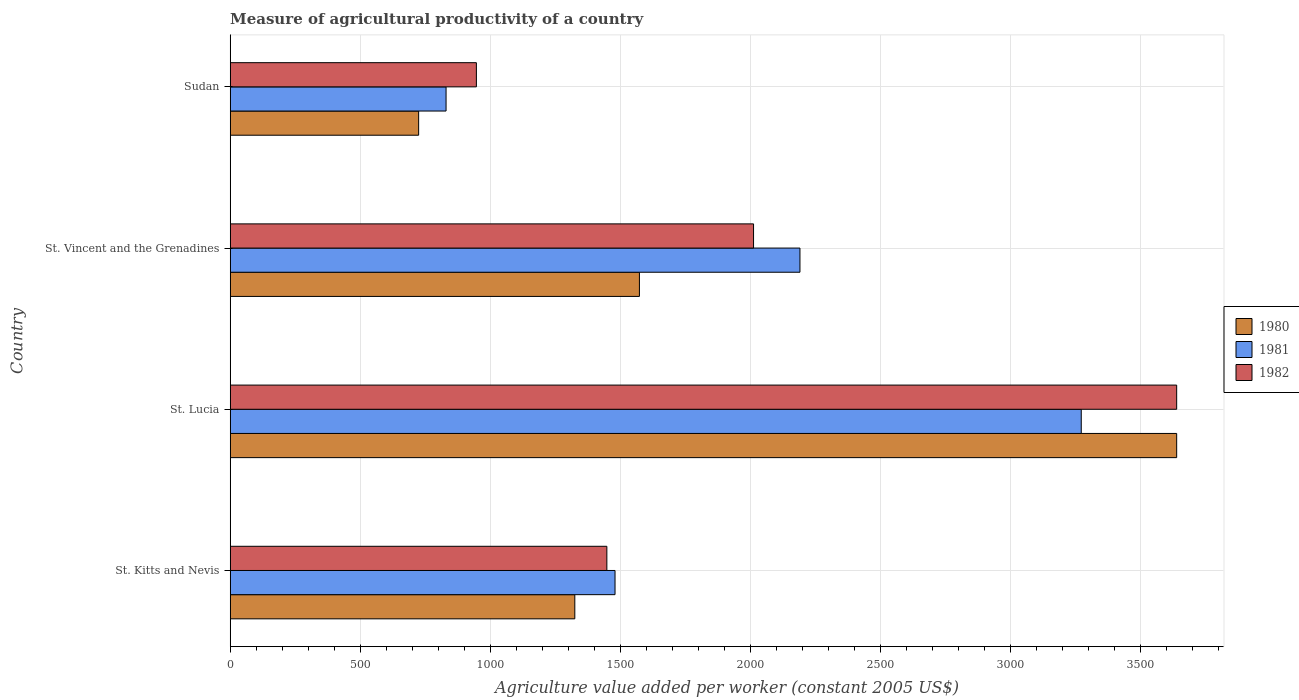How many different coloured bars are there?
Provide a short and direct response. 3. How many groups of bars are there?
Offer a very short reply. 4. Are the number of bars on each tick of the Y-axis equal?
Keep it short and to the point. Yes. How many bars are there on the 2nd tick from the top?
Make the answer very short. 3. How many bars are there on the 2nd tick from the bottom?
Offer a very short reply. 3. What is the label of the 4th group of bars from the top?
Make the answer very short. St. Kitts and Nevis. In how many cases, is the number of bars for a given country not equal to the number of legend labels?
Your response must be concise. 0. What is the measure of agricultural productivity in 1980 in St. Vincent and the Grenadines?
Ensure brevity in your answer.  1573.39. Across all countries, what is the maximum measure of agricultural productivity in 1980?
Provide a short and direct response. 3638.96. Across all countries, what is the minimum measure of agricultural productivity in 1982?
Ensure brevity in your answer.  946.58. In which country was the measure of agricultural productivity in 1982 maximum?
Keep it short and to the point. St. Lucia. In which country was the measure of agricultural productivity in 1980 minimum?
Keep it short and to the point. Sudan. What is the total measure of agricultural productivity in 1981 in the graph?
Give a very brief answer. 7772.33. What is the difference between the measure of agricultural productivity in 1980 in St. Lucia and that in St. Vincent and the Grenadines?
Provide a succinct answer. 2065.57. What is the difference between the measure of agricultural productivity in 1982 in Sudan and the measure of agricultural productivity in 1981 in St. Kitts and Nevis?
Offer a very short reply. -533.02. What is the average measure of agricultural productivity in 1982 per country?
Keep it short and to the point. 2011.48. What is the difference between the measure of agricultural productivity in 1980 and measure of agricultural productivity in 1982 in St. Vincent and the Grenadines?
Offer a terse response. -438.76. What is the ratio of the measure of agricultural productivity in 1982 in St. Lucia to that in St. Vincent and the Grenadines?
Offer a terse response. 1.81. Is the difference between the measure of agricultural productivity in 1980 in St. Kitts and Nevis and St. Lucia greater than the difference between the measure of agricultural productivity in 1982 in St. Kitts and Nevis and St. Lucia?
Provide a short and direct response. No. What is the difference between the highest and the second highest measure of agricultural productivity in 1980?
Your response must be concise. 2065.57. What is the difference between the highest and the lowest measure of agricultural productivity in 1980?
Keep it short and to the point. 2914.4. In how many countries, is the measure of agricultural productivity in 1980 greater than the average measure of agricultural productivity in 1980 taken over all countries?
Provide a short and direct response. 1. How many bars are there?
Make the answer very short. 12. How many countries are there in the graph?
Provide a succinct answer. 4. What is the difference between two consecutive major ticks on the X-axis?
Keep it short and to the point. 500. Where does the legend appear in the graph?
Make the answer very short. Center right. What is the title of the graph?
Give a very brief answer. Measure of agricultural productivity of a country. What is the label or title of the X-axis?
Provide a succinct answer. Agriculture value added per worker (constant 2005 US$). What is the label or title of the Y-axis?
Provide a succinct answer. Country. What is the Agriculture value added per worker (constant 2005 US$) of 1980 in St. Kitts and Nevis?
Make the answer very short. 1325. What is the Agriculture value added per worker (constant 2005 US$) in 1981 in St. Kitts and Nevis?
Make the answer very short. 1479.6. What is the Agriculture value added per worker (constant 2005 US$) in 1982 in St. Kitts and Nevis?
Keep it short and to the point. 1448.23. What is the Agriculture value added per worker (constant 2005 US$) of 1980 in St. Lucia?
Offer a terse response. 3638.96. What is the Agriculture value added per worker (constant 2005 US$) of 1981 in St. Lucia?
Ensure brevity in your answer.  3272.12. What is the Agriculture value added per worker (constant 2005 US$) of 1982 in St. Lucia?
Offer a very short reply. 3638.96. What is the Agriculture value added per worker (constant 2005 US$) in 1980 in St. Vincent and the Grenadines?
Your response must be concise. 1573.39. What is the Agriculture value added per worker (constant 2005 US$) in 1981 in St. Vincent and the Grenadines?
Provide a succinct answer. 2190.63. What is the Agriculture value added per worker (constant 2005 US$) in 1982 in St. Vincent and the Grenadines?
Offer a terse response. 2012.15. What is the Agriculture value added per worker (constant 2005 US$) of 1980 in Sudan?
Your answer should be compact. 724.57. What is the Agriculture value added per worker (constant 2005 US$) of 1981 in Sudan?
Provide a succinct answer. 829.99. What is the Agriculture value added per worker (constant 2005 US$) in 1982 in Sudan?
Provide a short and direct response. 946.58. Across all countries, what is the maximum Agriculture value added per worker (constant 2005 US$) in 1980?
Offer a terse response. 3638.96. Across all countries, what is the maximum Agriculture value added per worker (constant 2005 US$) in 1981?
Ensure brevity in your answer.  3272.12. Across all countries, what is the maximum Agriculture value added per worker (constant 2005 US$) in 1982?
Give a very brief answer. 3638.96. Across all countries, what is the minimum Agriculture value added per worker (constant 2005 US$) in 1980?
Provide a short and direct response. 724.57. Across all countries, what is the minimum Agriculture value added per worker (constant 2005 US$) of 1981?
Your response must be concise. 829.99. Across all countries, what is the minimum Agriculture value added per worker (constant 2005 US$) of 1982?
Give a very brief answer. 946.58. What is the total Agriculture value added per worker (constant 2005 US$) of 1980 in the graph?
Make the answer very short. 7261.93. What is the total Agriculture value added per worker (constant 2005 US$) of 1981 in the graph?
Your answer should be compact. 7772.33. What is the total Agriculture value added per worker (constant 2005 US$) in 1982 in the graph?
Offer a very short reply. 8045.93. What is the difference between the Agriculture value added per worker (constant 2005 US$) in 1980 in St. Kitts and Nevis and that in St. Lucia?
Give a very brief answer. -2313.96. What is the difference between the Agriculture value added per worker (constant 2005 US$) of 1981 in St. Kitts and Nevis and that in St. Lucia?
Your answer should be very brief. -1792.52. What is the difference between the Agriculture value added per worker (constant 2005 US$) of 1982 in St. Kitts and Nevis and that in St. Lucia?
Give a very brief answer. -2190.74. What is the difference between the Agriculture value added per worker (constant 2005 US$) in 1980 in St. Kitts and Nevis and that in St. Vincent and the Grenadines?
Offer a very short reply. -248.39. What is the difference between the Agriculture value added per worker (constant 2005 US$) of 1981 in St. Kitts and Nevis and that in St. Vincent and the Grenadines?
Your answer should be compact. -711.03. What is the difference between the Agriculture value added per worker (constant 2005 US$) of 1982 in St. Kitts and Nevis and that in St. Vincent and the Grenadines?
Your answer should be compact. -563.93. What is the difference between the Agriculture value added per worker (constant 2005 US$) of 1980 in St. Kitts and Nevis and that in Sudan?
Provide a short and direct response. 600.43. What is the difference between the Agriculture value added per worker (constant 2005 US$) in 1981 in St. Kitts and Nevis and that in Sudan?
Ensure brevity in your answer.  649.61. What is the difference between the Agriculture value added per worker (constant 2005 US$) in 1982 in St. Kitts and Nevis and that in Sudan?
Provide a succinct answer. 501.65. What is the difference between the Agriculture value added per worker (constant 2005 US$) of 1980 in St. Lucia and that in St. Vincent and the Grenadines?
Your response must be concise. 2065.57. What is the difference between the Agriculture value added per worker (constant 2005 US$) in 1981 in St. Lucia and that in St. Vincent and the Grenadines?
Provide a succinct answer. 1081.49. What is the difference between the Agriculture value added per worker (constant 2005 US$) in 1982 in St. Lucia and that in St. Vincent and the Grenadines?
Provide a short and direct response. 1626.81. What is the difference between the Agriculture value added per worker (constant 2005 US$) of 1980 in St. Lucia and that in Sudan?
Offer a very short reply. 2914.4. What is the difference between the Agriculture value added per worker (constant 2005 US$) of 1981 in St. Lucia and that in Sudan?
Your response must be concise. 2442.13. What is the difference between the Agriculture value added per worker (constant 2005 US$) of 1982 in St. Lucia and that in Sudan?
Provide a short and direct response. 2692.39. What is the difference between the Agriculture value added per worker (constant 2005 US$) in 1980 in St. Vincent and the Grenadines and that in Sudan?
Keep it short and to the point. 848.82. What is the difference between the Agriculture value added per worker (constant 2005 US$) in 1981 in St. Vincent and the Grenadines and that in Sudan?
Give a very brief answer. 1360.64. What is the difference between the Agriculture value added per worker (constant 2005 US$) of 1982 in St. Vincent and the Grenadines and that in Sudan?
Offer a very short reply. 1065.58. What is the difference between the Agriculture value added per worker (constant 2005 US$) of 1980 in St. Kitts and Nevis and the Agriculture value added per worker (constant 2005 US$) of 1981 in St. Lucia?
Your answer should be compact. -1947.12. What is the difference between the Agriculture value added per worker (constant 2005 US$) of 1980 in St. Kitts and Nevis and the Agriculture value added per worker (constant 2005 US$) of 1982 in St. Lucia?
Ensure brevity in your answer.  -2313.96. What is the difference between the Agriculture value added per worker (constant 2005 US$) in 1981 in St. Kitts and Nevis and the Agriculture value added per worker (constant 2005 US$) in 1982 in St. Lucia?
Provide a short and direct response. -2159.37. What is the difference between the Agriculture value added per worker (constant 2005 US$) in 1980 in St. Kitts and Nevis and the Agriculture value added per worker (constant 2005 US$) in 1981 in St. Vincent and the Grenadines?
Make the answer very short. -865.63. What is the difference between the Agriculture value added per worker (constant 2005 US$) in 1980 in St. Kitts and Nevis and the Agriculture value added per worker (constant 2005 US$) in 1982 in St. Vincent and the Grenadines?
Your answer should be compact. -687.15. What is the difference between the Agriculture value added per worker (constant 2005 US$) in 1981 in St. Kitts and Nevis and the Agriculture value added per worker (constant 2005 US$) in 1982 in St. Vincent and the Grenadines?
Provide a short and direct response. -532.56. What is the difference between the Agriculture value added per worker (constant 2005 US$) in 1980 in St. Kitts and Nevis and the Agriculture value added per worker (constant 2005 US$) in 1981 in Sudan?
Give a very brief answer. 495.01. What is the difference between the Agriculture value added per worker (constant 2005 US$) in 1980 in St. Kitts and Nevis and the Agriculture value added per worker (constant 2005 US$) in 1982 in Sudan?
Offer a terse response. 378.42. What is the difference between the Agriculture value added per worker (constant 2005 US$) in 1981 in St. Kitts and Nevis and the Agriculture value added per worker (constant 2005 US$) in 1982 in Sudan?
Keep it short and to the point. 533.02. What is the difference between the Agriculture value added per worker (constant 2005 US$) of 1980 in St. Lucia and the Agriculture value added per worker (constant 2005 US$) of 1981 in St. Vincent and the Grenadines?
Your response must be concise. 1448.34. What is the difference between the Agriculture value added per worker (constant 2005 US$) of 1980 in St. Lucia and the Agriculture value added per worker (constant 2005 US$) of 1982 in St. Vincent and the Grenadines?
Your answer should be compact. 1626.81. What is the difference between the Agriculture value added per worker (constant 2005 US$) in 1981 in St. Lucia and the Agriculture value added per worker (constant 2005 US$) in 1982 in St. Vincent and the Grenadines?
Your answer should be compact. 1259.97. What is the difference between the Agriculture value added per worker (constant 2005 US$) in 1980 in St. Lucia and the Agriculture value added per worker (constant 2005 US$) in 1981 in Sudan?
Keep it short and to the point. 2808.98. What is the difference between the Agriculture value added per worker (constant 2005 US$) of 1980 in St. Lucia and the Agriculture value added per worker (constant 2005 US$) of 1982 in Sudan?
Offer a very short reply. 2692.39. What is the difference between the Agriculture value added per worker (constant 2005 US$) of 1981 in St. Lucia and the Agriculture value added per worker (constant 2005 US$) of 1982 in Sudan?
Your answer should be compact. 2325.54. What is the difference between the Agriculture value added per worker (constant 2005 US$) in 1980 in St. Vincent and the Grenadines and the Agriculture value added per worker (constant 2005 US$) in 1981 in Sudan?
Your answer should be very brief. 743.4. What is the difference between the Agriculture value added per worker (constant 2005 US$) in 1980 in St. Vincent and the Grenadines and the Agriculture value added per worker (constant 2005 US$) in 1982 in Sudan?
Your response must be concise. 626.81. What is the difference between the Agriculture value added per worker (constant 2005 US$) of 1981 in St. Vincent and the Grenadines and the Agriculture value added per worker (constant 2005 US$) of 1982 in Sudan?
Provide a short and direct response. 1244.05. What is the average Agriculture value added per worker (constant 2005 US$) of 1980 per country?
Provide a short and direct response. 1815.48. What is the average Agriculture value added per worker (constant 2005 US$) in 1981 per country?
Keep it short and to the point. 1943.08. What is the average Agriculture value added per worker (constant 2005 US$) of 1982 per country?
Keep it short and to the point. 2011.48. What is the difference between the Agriculture value added per worker (constant 2005 US$) of 1980 and Agriculture value added per worker (constant 2005 US$) of 1981 in St. Kitts and Nevis?
Ensure brevity in your answer.  -154.6. What is the difference between the Agriculture value added per worker (constant 2005 US$) in 1980 and Agriculture value added per worker (constant 2005 US$) in 1982 in St. Kitts and Nevis?
Provide a succinct answer. -123.23. What is the difference between the Agriculture value added per worker (constant 2005 US$) of 1981 and Agriculture value added per worker (constant 2005 US$) of 1982 in St. Kitts and Nevis?
Provide a short and direct response. 31.37. What is the difference between the Agriculture value added per worker (constant 2005 US$) in 1980 and Agriculture value added per worker (constant 2005 US$) in 1981 in St. Lucia?
Provide a succinct answer. 366.84. What is the difference between the Agriculture value added per worker (constant 2005 US$) in 1980 and Agriculture value added per worker (constant 2005 US$) in 1982 in St. Lucia?
Ensure brevity in your answer.  0. What is the difference between the Agriculture value added per worker (constant 2005 US$) in 1981 and Agriculture value added per worker (constant 2005 US$) in 1982 in St. Lucia?
Your answer should be very brief. -366.84. What is the difference between the Agriculture value added per worker (constant 2005 US$) of 1980 and Agriculture value added per worker (constant 2005 US$) of 1981 in St. Vincent and the Grenadines?
Your response must be concise. -617.23. What is the difference between the Agriculture value added per worker (constant 2005 US$) in 1980 and Agriculture value added per worker (constant 2005 US$) in 1982 in St. Vincent and the Grenadines?
Your answer should be very brief. -438.76. What is the difference between the Agriculture value added per worker (constant 2005 US$) of 1981 and Agriculture value added per worker (constant 2005 US$) of 1982 in St. Vincent and the Grenadines?
Offer a terse response. 178.47. What is the difference between the Agriculture value added per worker (constant 2005 US$) in 1980 and Agriculture value added per worker (constant 2005 US$) in 1981 in Sudan?
Provide a short and direct response. -105.42. What is the difference between the Agriculture value added per worker (constant 2005 US$) in 1980 and Agriculture value added per worker (constant 2005 US$) in 1982 in Sudan?
Offer a very short reply. -222.01. What is the difference between the Agriculture value added per worker (constant 2005 US$) in 1981 and Agriculture value added per worker (constant 2005 US$) in 1982 in Sudan?
Your response must be concise. -116.59. What is the ratio of the Agriculture value added per worker (constant 2005 US$) of 1980 in St. Kitts and Nevis to that in St. Lucia?
Keep it short and to the point. 0.36. What is the ratio of the Agriculture value added per worker (constant 2005 US$) of 1981 in St. Kitts and Nevis to that in St. Lucia?
Offer a very short reply. 0.45. What is the ratio of the Agriculture value added per worker (constant 2005 US$) of 1982 in St. Kitts and Nevis to that in St. Lucia?
Ensure brevity in your answer.  0.4. What is the ratio of the Agriculture value added per worker (constant 2005 US$) of 1980 in St. Kitts and Nevis to that in St. Vincent and the Grenadines?
Your response must be concise. 0.84. What is the ratio of the Agriculture value added per worker (constant 2005 US$) in 1981 in St. Kitts and Nevis to that in St. Vincent and the Grenadines?
Your response must be concise. 0.68. What is the ratio of the Agriculture value added per worker (constant 2005 US$) of 1982 in St. Kitts and Nevis to that in St. Vincent and the Grenadines?
Make the answer very short. 0.72. What is the ratio of the Agriculture value added per worker (constant 2005 US$) of 1980 in St. Kitts and Nevis to that in Sudan?
Offer a terse response. 1.83. What is the ratio of the Agriculture value added per worker (constant 2005 US$) in 1981 in St. Kitts and Nevis to that in Sudan?
Provide a short and direct response. 1.78. What is the ratio of the Agriculture value added per worker (constant 2005 US$) in 1982 in St. Kitts and Nevis to that in Sudan?
Keep it short and to the point. 1.53. What is the ratio of the Agriculture value added per worker (constant 2005 US$) of 1980 in St. Lucia to that in St. Vincent and the Grenadines?
Your answer should be compact. 2.31. What is the ratio of the Agriculture value added per worker (constant 2005 US$) in 1981 in St. Lucia to that in St. Vincent and the Grenadines?
Offer a terse response. 1.49. What is the ratio of the Agriculture value added per worker (constant 2005 US$) in 1982 in St. Lucia to that in St. Vincent and the Grenadines?
Give a very brief answer. 1.81. What is the ratio of the Agriculture value added per worker (constant 2005 US$) of 1980 in St. Lucia to that in Sudan?
Give a very brief answer. 5.02. What is the ratio of the Agriculture value added per worker (constant 2005 US$) of 1981 in St. Lucia to that in Sudan?
Your response must be concise. 3.94. What is the ratio of the Agriculture value added per worker (constant 2005 US$) in 1982 in St. Lucia to that in Sudan?
Offer a terse response. 3.84. What is the ratio of the Agriculture value added per worker (constant 2005 US$) in 1980 in St. Vincent and the Grenadines to that in Sudan?
Offer a very short reply. 2.17. What is the ratio of the Agriculture value added per worker (constant 2005 US$) of 1981 in St. Vincent and the Grenadines to that in Sudan?
Provide a short and direct response. 2.64. What is the ratio of the Agriculture value added per worker (constant 2005 US$) in 1982 in St. Vincent and the Grenadines to that in Sudan?
Ensure brevity in your answer.  2.13. What is the difference between the highest and the second highest Agriculture value added per worker (constant 2005 US$) in 1980?
Offer a very short reply. 2065.57. What is the difference between the highest and the second highest Agriculture value added per worker (constant 2005 US$) in 1981?
Provide a short and direct response. 1081.49. What is the difference between the highest and the second highest Agriculture value added per worker (constant 2005 US$) in 1982?
Ensure brevity in your answer.  1626.81. What is the difference between the highest and the lowest Agriculture value added per worker (constant 2005 US$) in 1980?
Your answer should be compact. 2914.4. What is the difference between the highest and the lowest Agriculture value added per worker (constant 2005 US$) in 1981?
Provide a succinct answer. 2442.13. What is the difference between the highest and the lowest Agriculture value added per worker (constant 2005 US$) in 1982?
Make the answer very short. 2692.39. 